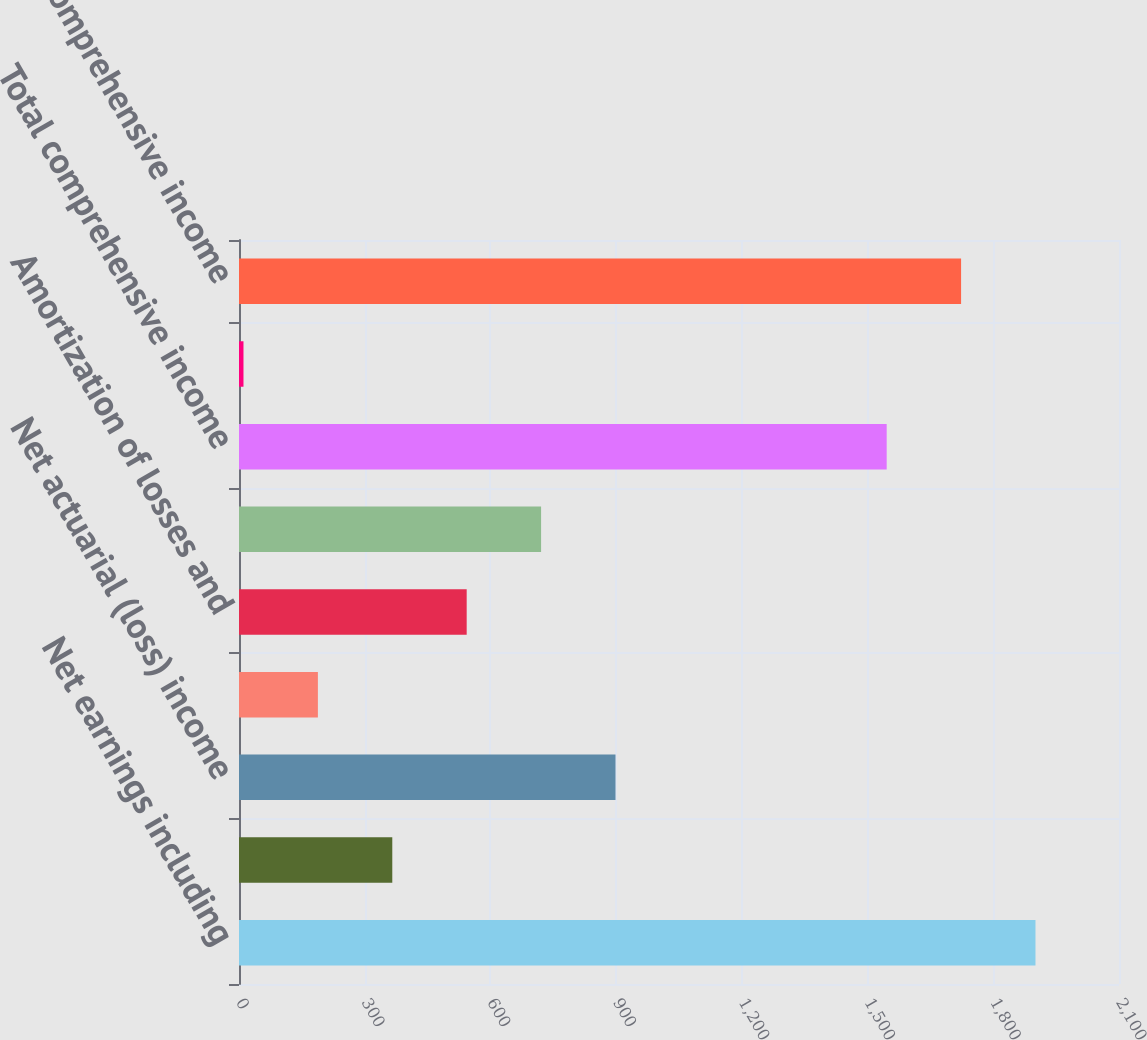<chart> <loc_0><loc_0><loc_500><loc_500><bar_chart><fcel>Net earnings including<fcel>Foreign currency translation<fcel>Net actuarial (loss) income<fcel>Hedge derivatives<fcel>Amortization of losses and<fcel>Other comprehensive (loss)<fcel>Total comprehensive income<fcel>Comprehensive (loss) income<fcel>Comprehensive income<nl><fcel>1900.7<fcel>365.8<fcel>898.45<fcel>188.25<fcel>543.35<fcel>720.9<fcel>1545.6<fcel>10.7<fcel>1723.15<nl></chart> 